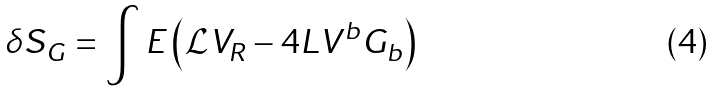Convert formula to latex. <formula><loc_0><loc_0><loc_500><loc_500>\delta S _ { G } = \int E \left ( \mathcal { L } V _ { R } - 4 L V ^ { b } G _ { b } \right )</formula> 